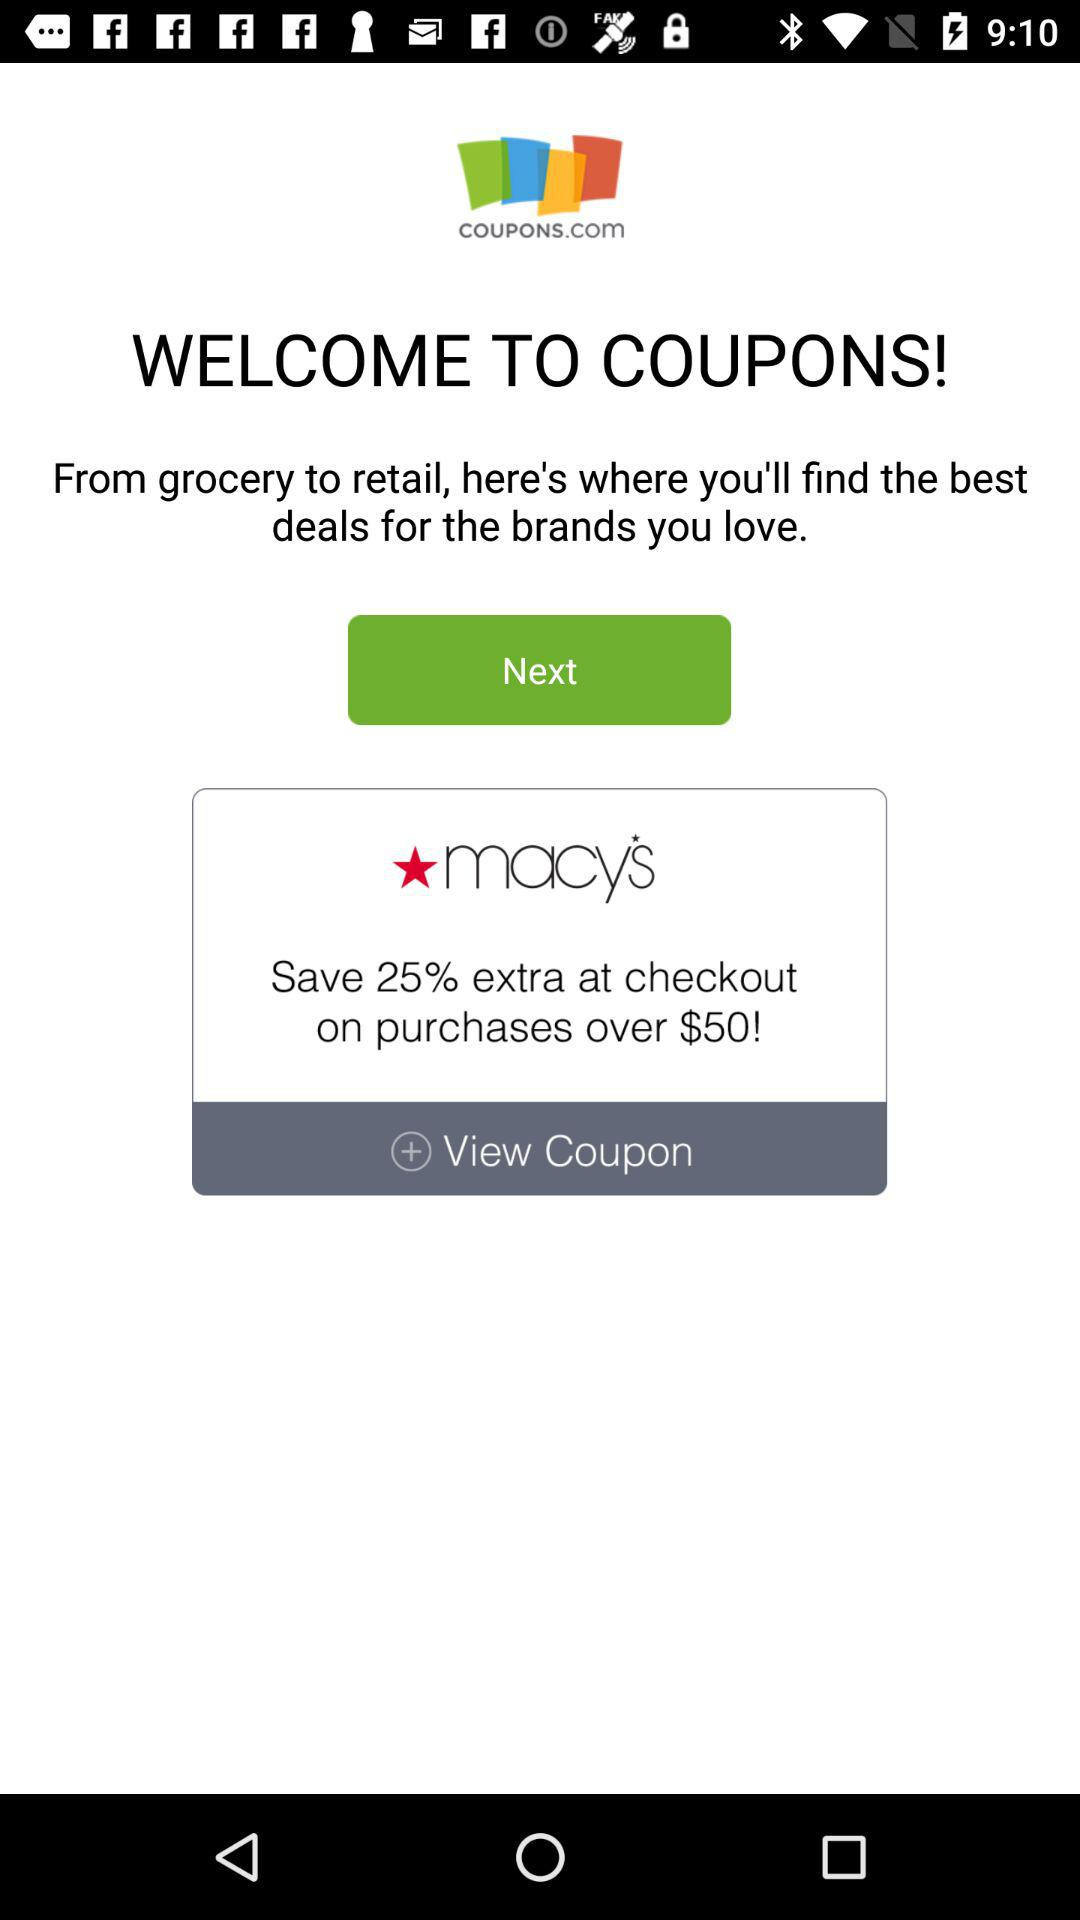How much extra discount will one get on purchases over $50? On purchases over $50, one will get an extra discount of 25%. 